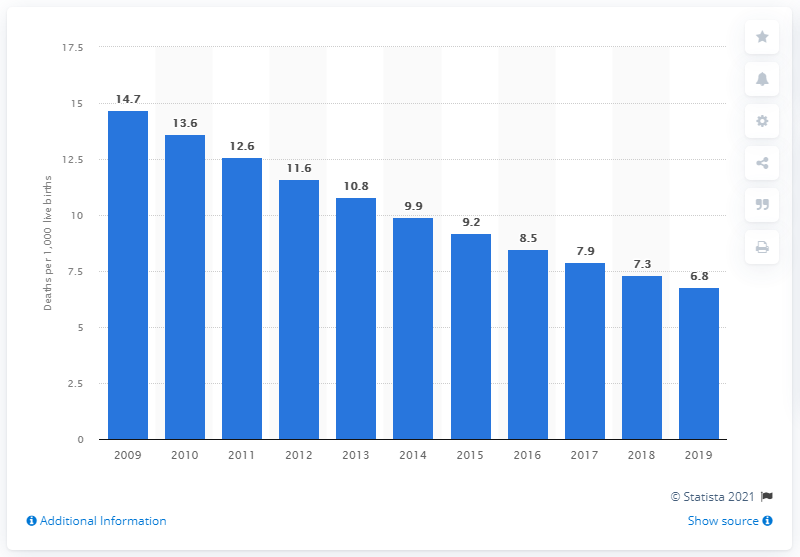Draw attention to some important aspects in this diagram. The infant mortality rate in China in 2019 was 6.8 per 1,000 live births. 